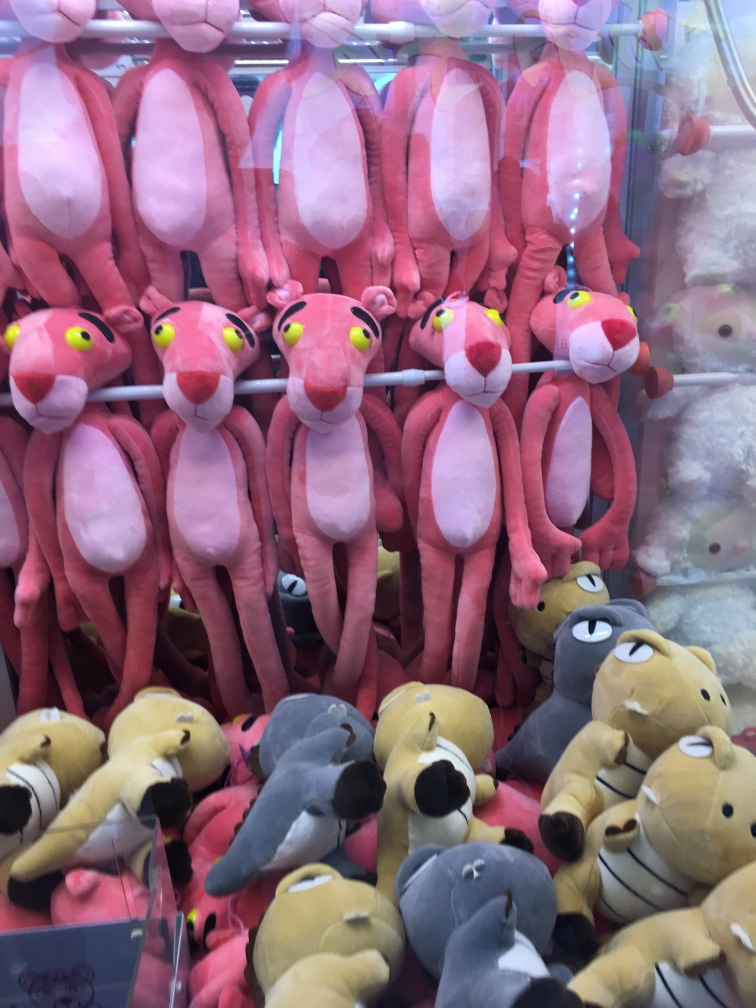Can you tell me about the toys in the foreground? Certainly, the plush toys in the foreground are various cartoon-like animals, with a predominant theme of pink Panther characters that are in sharp focus, suggesting that they are the primary subject of the photograph. What might these toys be used for? These toys are often purchased as gifts or collectibles. They could also be prizes at a carnival game or part of merchandise for a specific character franchise, being soft and cuddly, they cater to all age groups. 